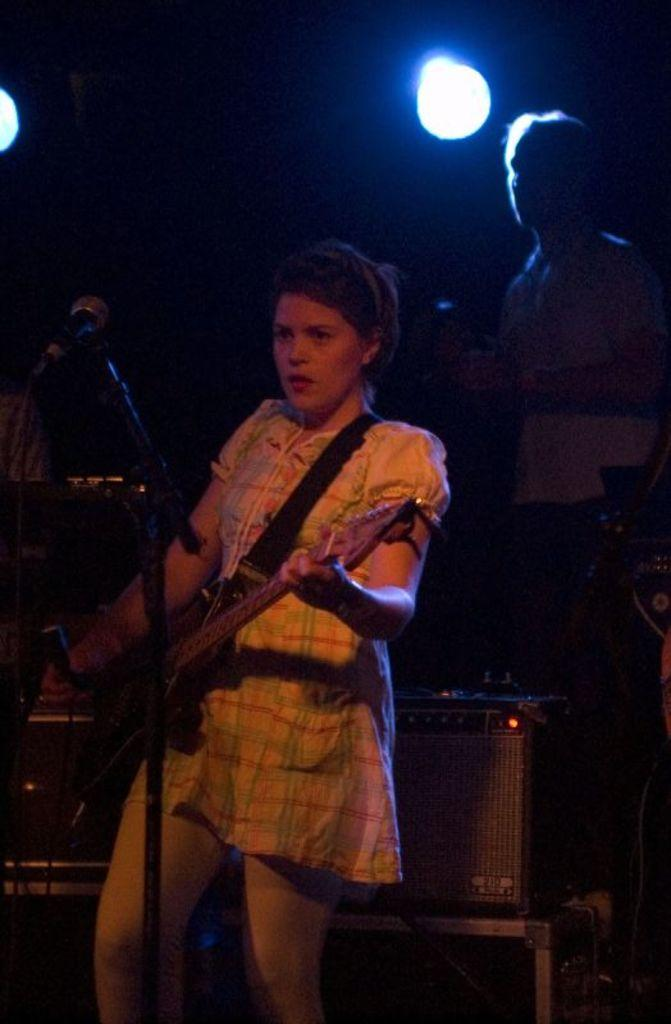Who is the main subject in the image? There is a woman in the image. What is the woman doing in the image? The woman is standing in the image. What object is the woman holding in her hand? The woman is holding a guitar in her hand. What type of veil is the woman wearing in the image? There is no veil present in the image; the woman is holding a guitar. What type of servant is depicted in the image? There is no servant depicted in the image; the main subject is a woman holding a guitar. 